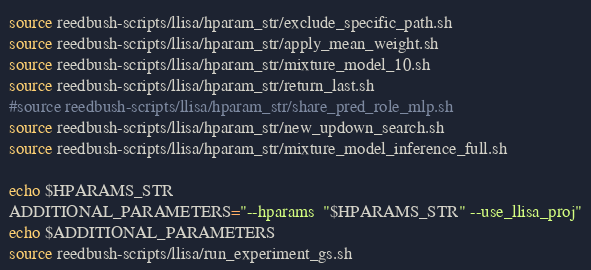<code> <loc_0><loc_0><loc_500><loc_500><_Bash_>source reedbush-scripts/llisa/hparam_str/exclude_specific_path.sh
source reedbush-scripts/llisa/hparam_str/apply_mean_weight.sh
source reedbush-scripts/llisa/hparam_str/mixture_model_10.sh
source reedbush-scripts/llisa/hparam_str/return_last.sh
#source reedbush-scripts/llisa/hparam_str/share_pred_role_mlp.sh
source reedbush-scripts/llisa/hparam_str/new_updown_search.sh
source reedbush-scripts/llisa/hparam_str/mixture_model_inference_full.sh

echo $HPARAMS_STR
ADDITIONAL_PARAMETERS="--hparams  "$HPARAMS_STR" --use_llisa_proj"
echo $ADDITIONAL_PARAMETERS
source reedbush-scripts/llisa/run_experiment_gs.sh
</code> 